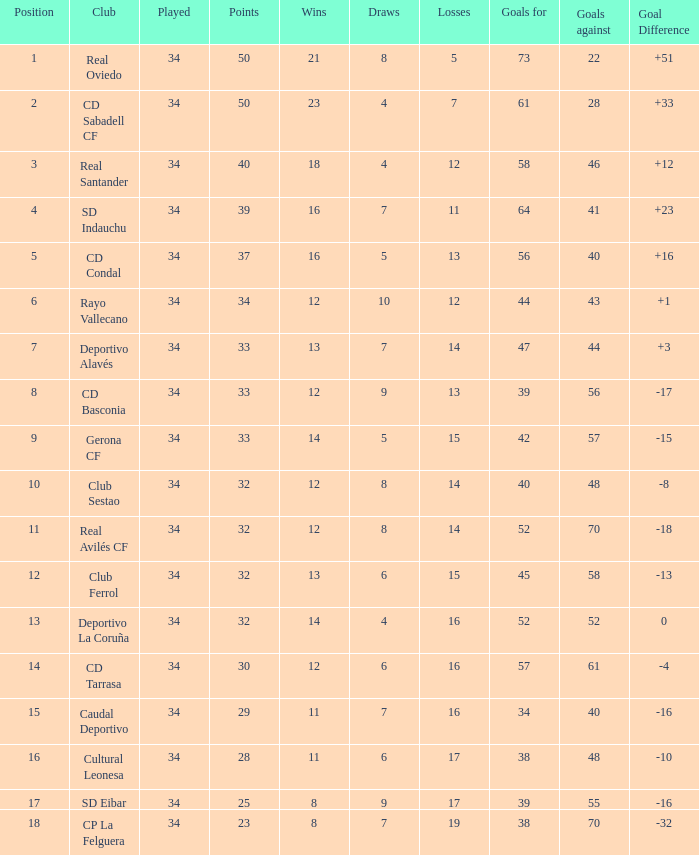Which teams have a goal difference of -16 and fewer than 8 victories? None. 